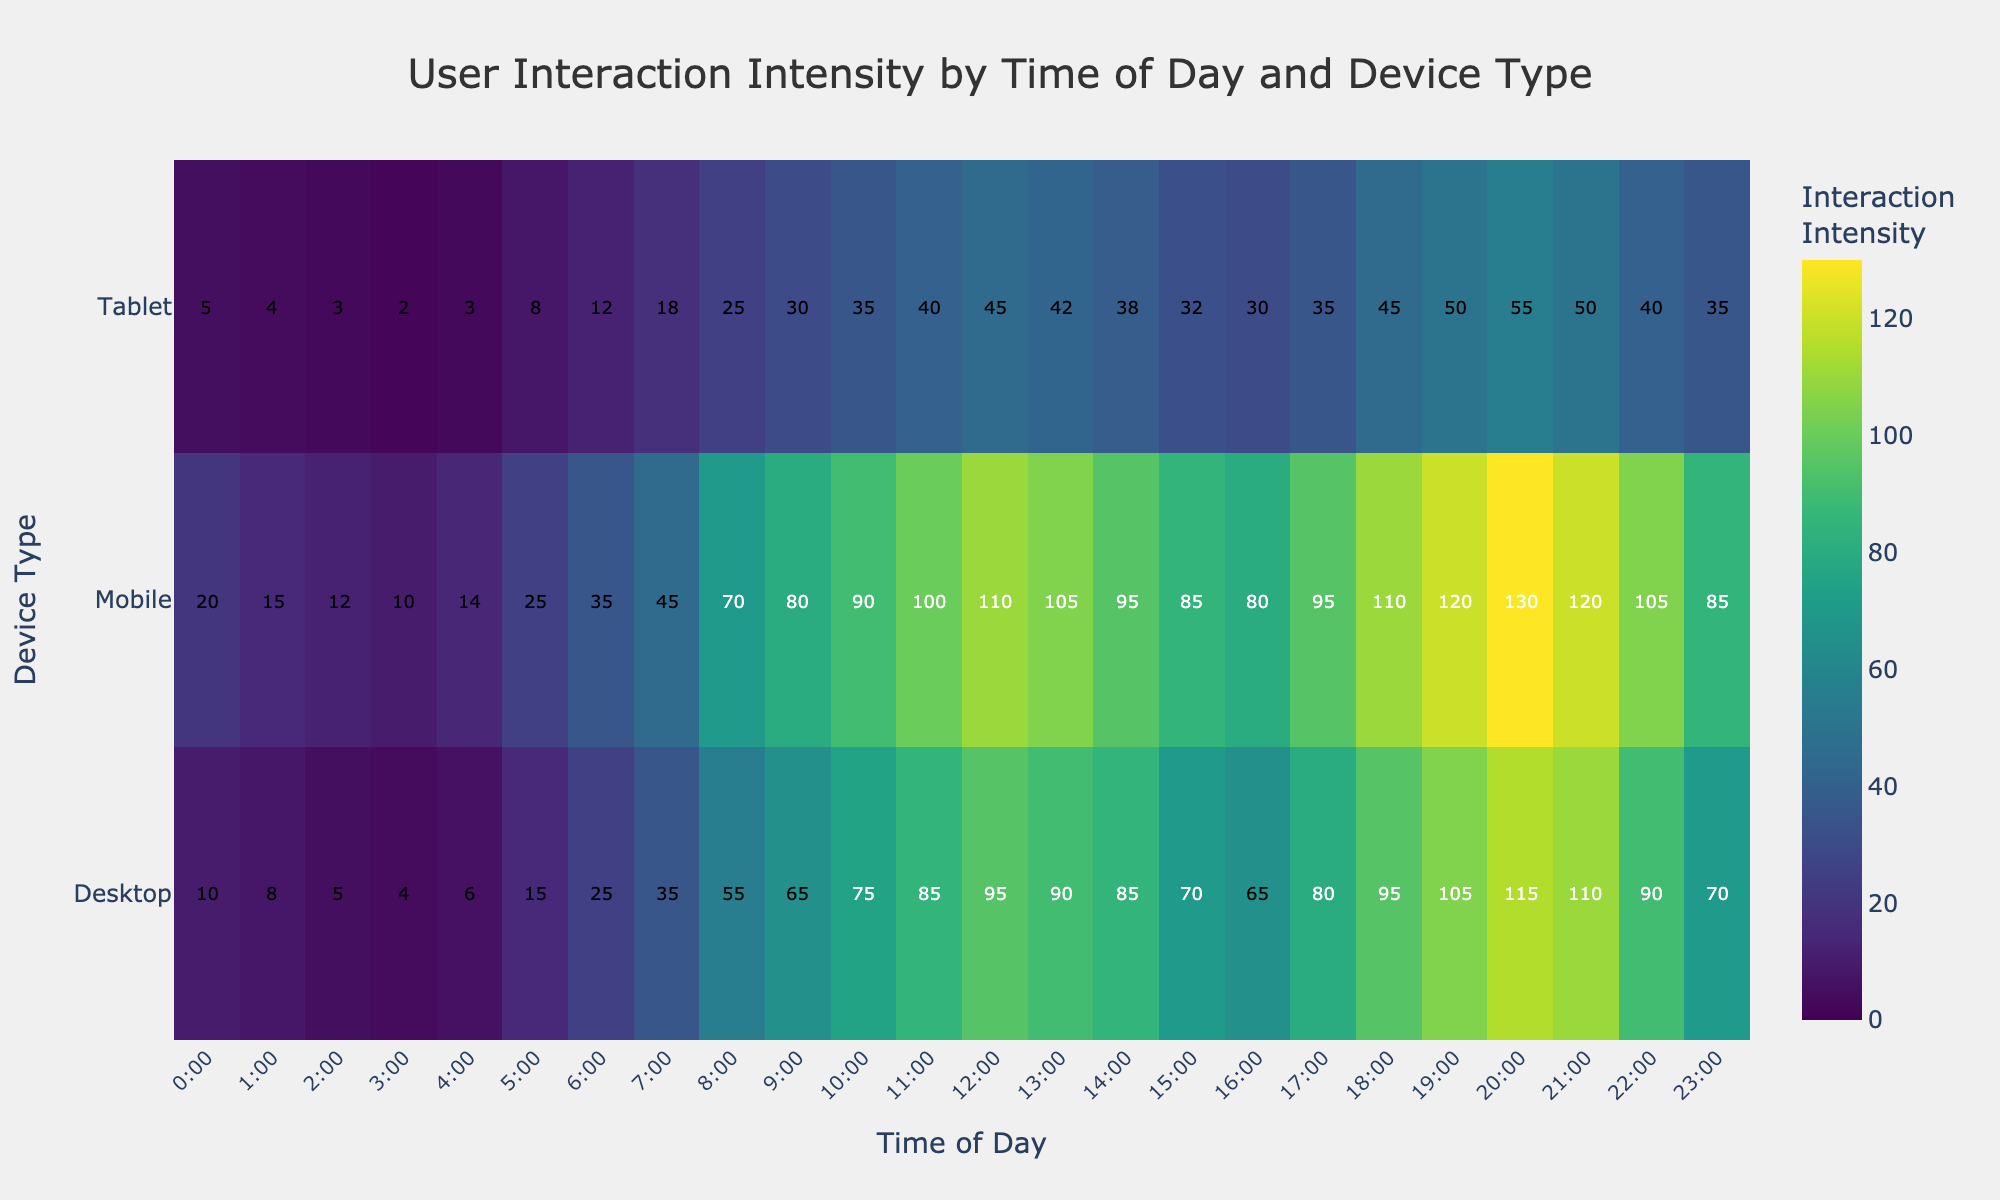What is the title of the heatmap? The title of the heatmap is usually found at the top center of the chart. In this case, it reads "User Interaction Intensity by Time of Day and Device Type".
Answer: User Interaction Intensity by Time of Day and Device Type What are the three device types shown on the y-axis? The y-axis has three categories listed, which are "Desktop", "Mobile", and "Tablet".
Answer: Desktop, Mobile, Tablet At what time of day is the interaction intensity the highest for mobile devices? You need to look at the row corresponding to 'Mobile' and find the highest intensity value. The maximum value for Mobile is 130 at 20:00.
Answer: 20:00 How does the interaction intensity at 12:00 for Desktop compare to Tablet? Find the values at 12:00 for Desktop and Tablet. Desktop is 95 and Tablet is 45. Desktop has a higher intensity.
Answer: Desktop is higher What is the average interaction intensity for Desktop devices from 0:00 to 4:00? Sum the values from 0:00 to 4:00 (10 + 8 + 5 + 4 + 6 = 33) and divide by 5.
Answer: 6.6 Which device type shows the least interaction intensity at 2:00? Compare the values at 2:00 across Desktop, Mobile, and Tablet. They are 5, 12, and 3, respectively. Tablet has the lowest interaction.
Answer: Tablet What times of day show an interaction intensity for Mobile devices greater than 100? Look at the row for Mobile and find times where the values are greater than 100. These are 12:00, 18:00, 19:00, 20:00, and 21:00.
Answer: 12:00, 18:00, 19:00, 20:00, 21:00 Compare the interaction intensity between Mobile and Tablet at 17:00. Find the values at 17:00 for both Mobile and Tablet. Mobile shows 95, while Tablet shows 35. Mobile has a higher intensity.
Answer: Mobile is higher 